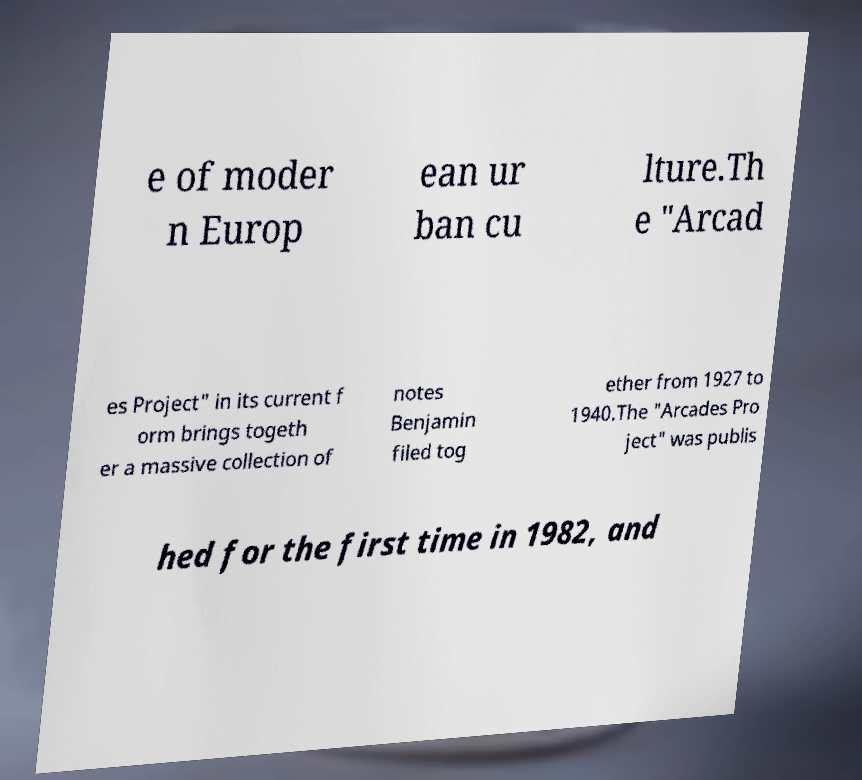Could you assist in decoding the text presented in this image and type it out clearly? e of moder n Europ ean ur ban cu lture.Th e "Arcad es Project" in its current f orm brings togeth er a massive collection of notes Benjamin filed tog ether from 1927 to 1940.The "Arcades Pro ject" was publis hed for the first time in 1982, and 